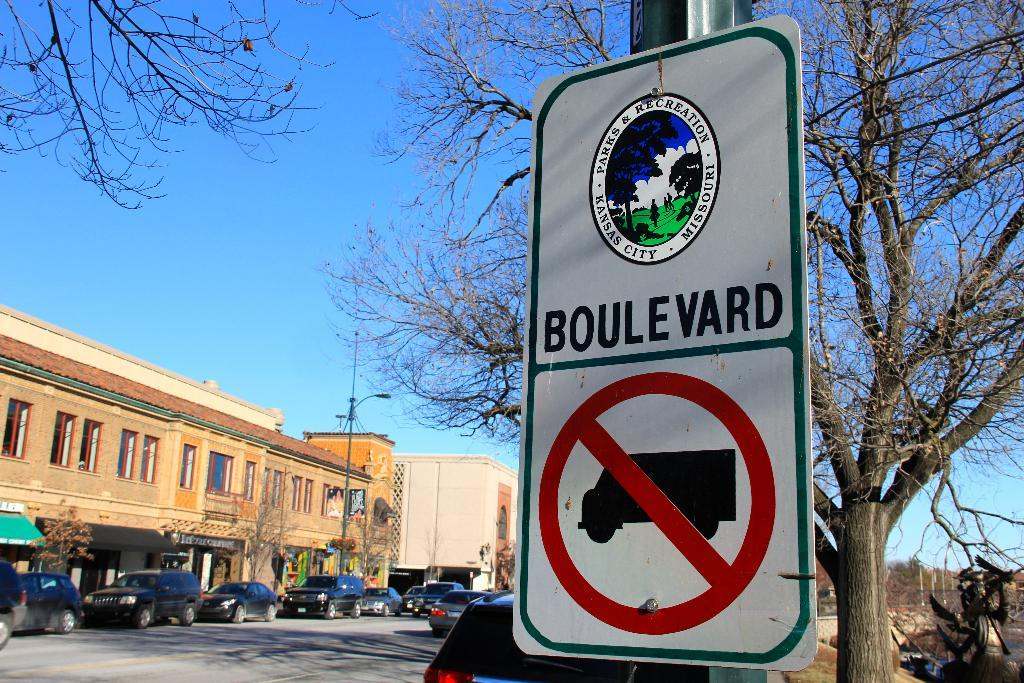<image>
Describe the image concisely. A Kansas City Parks and Recreation sign shows that trucks are prohibited. 